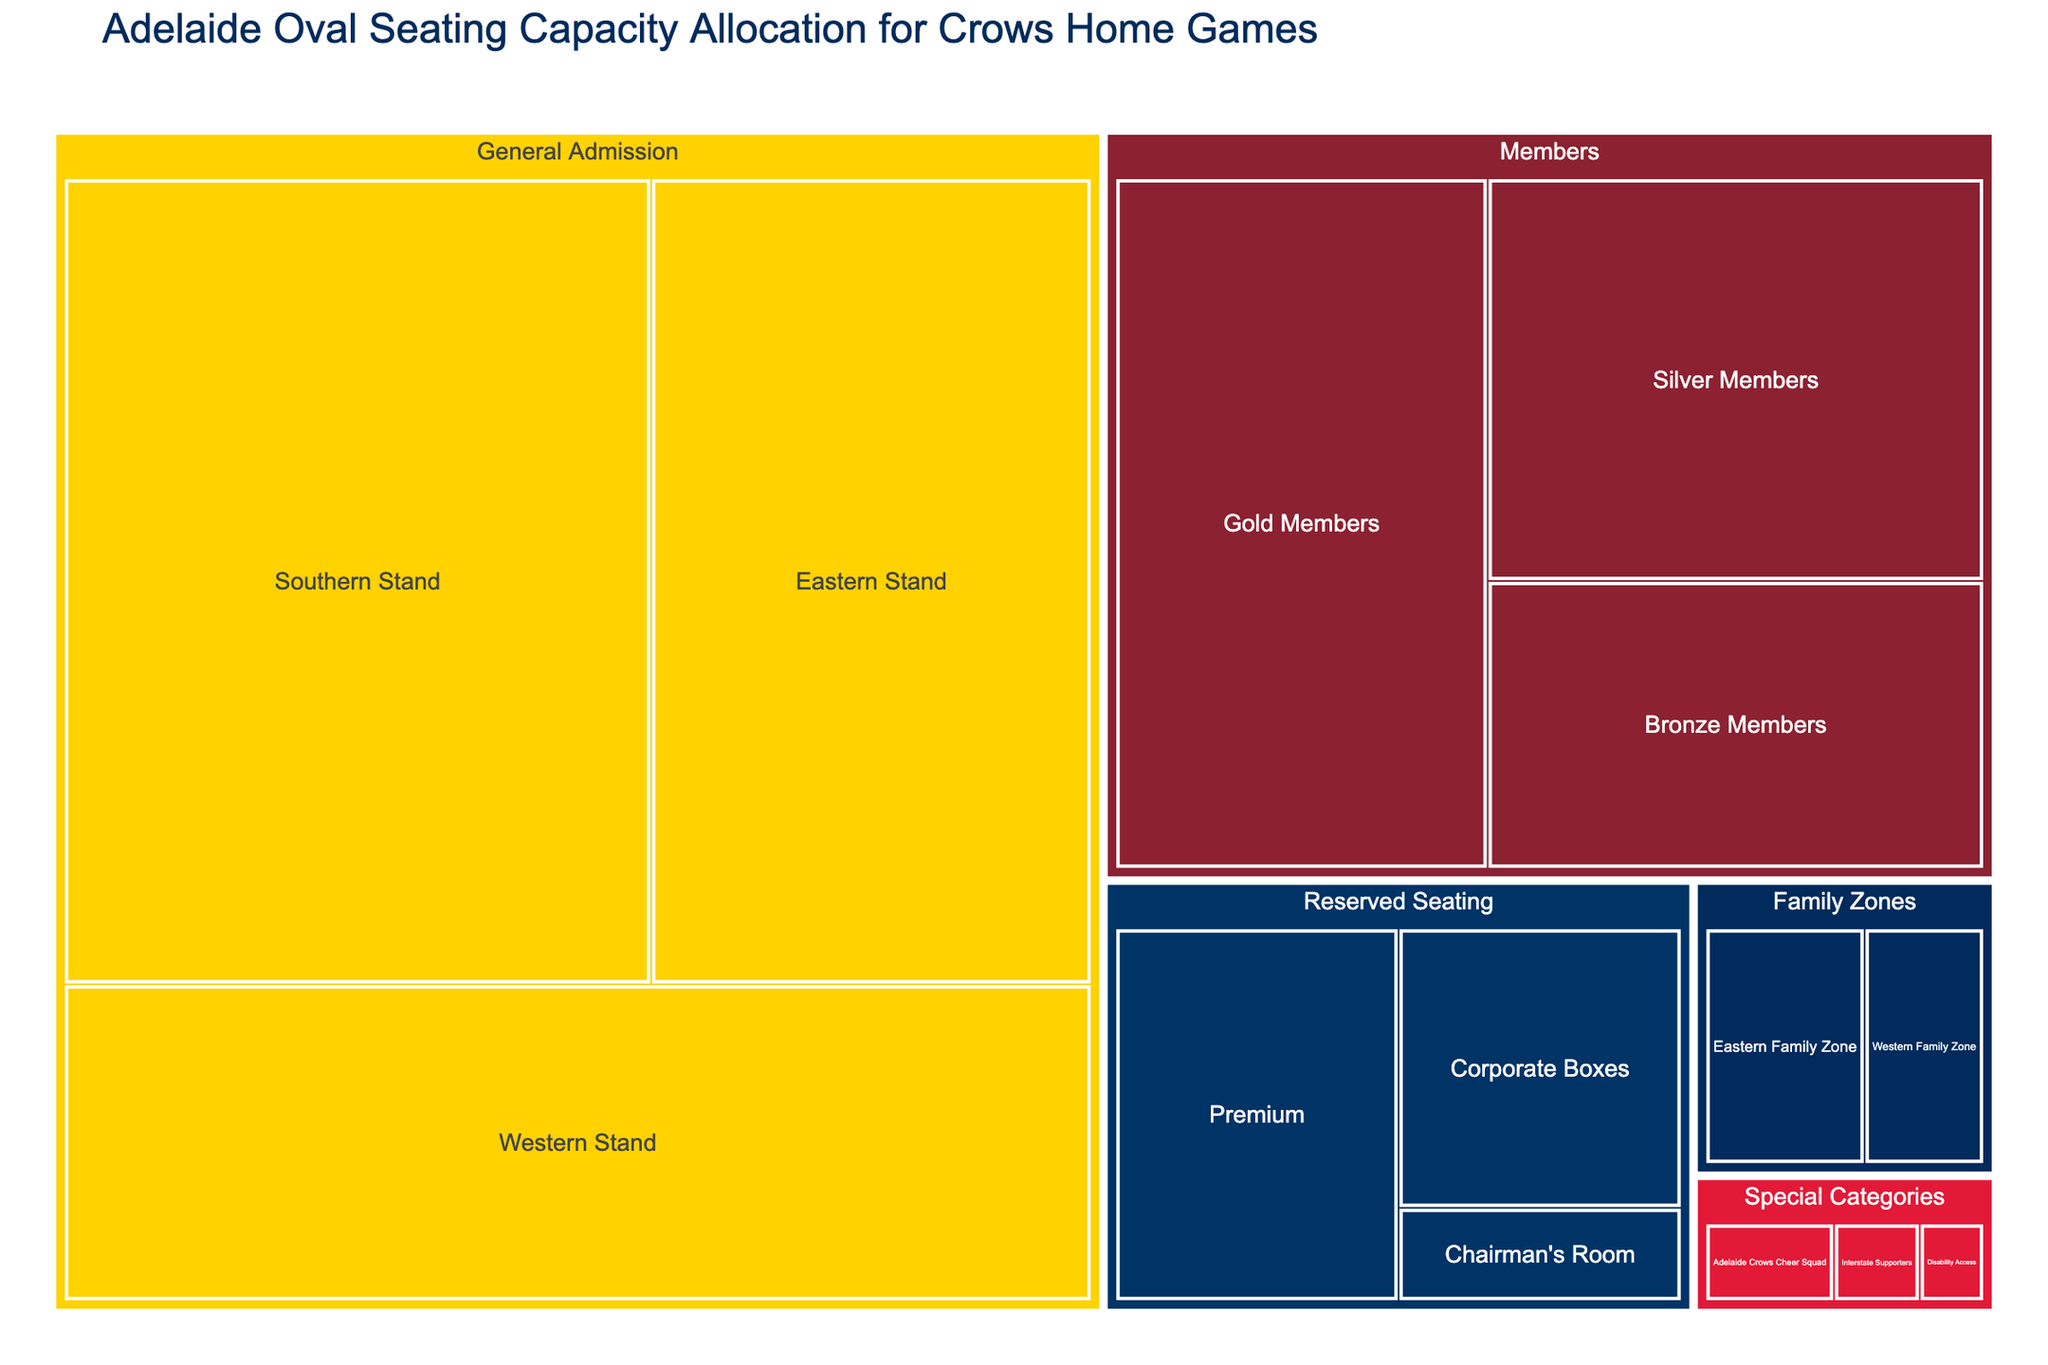Which stand has the highest general admission seating capacity? Find the part labeled 'General Admission' and compare the values for the Southern Stand (8000), Eastern Stand (6000), and Western Stand (5500). The Southern Stand has the highest value.
Answer: Southern Stand How many categories are represented in this treemap? Identify the top-level categories listed in the figure. They are General Admission, Members, Reserved Seating, Special Categories, and Family Zones. Count these categories.
Answer: 5 What is the total seating capacity for the 'Members' category? Sum the values within the 'Members' category: Gold Members (4500), Silver Members (3500), and Bronze Members (2500). \(4500 + 3500 + 2500\) = 10500.
Answer: 10500 Which category has the smallest seating capacity, and what is that capacity? Analyze the seating capacities of each top-level category: General Admission, Members, Reserved Seating, Special Categories, and Family Zones. Identify that 'Special Categories' has the smallest overall capacity. Within 'Special Categories', check the values: Adelaide Crows Cheer Squad (300), Interstate Supporters (200), and Disability Access (150). The minimum is 150 for Disability Access.
Answer: Special Categories, 150 Is the capacity of the Western Family Zone greater than the capacity of Corporate Boxes? Compare the seating capacity values listed for the Western Family Zone (600) and Corporate Boxes (1500). Determine that 600 is less than 1500.
Answer: No What is the combined capacity of the 'Reserved Seating' category? Locate the 'Reserved Seating' category and sum its subcategories: Premium (2000), Corporate Boxes (1500), and Chairman's Room (500). Calculate \(2000 + 1500 + 500\) = 4000.
Answer: 4000 Compare the capacity of 'Eastern Stand' within General Admission and the 'Eastern Family Zone'. Which one has a higher capacity? Look at the values for the Eastern Stand in 'General Admission' (6000) and Eastern Family Zone within 'Family Zones' (800). Compare these values to see that 6000 is greater than 800.
Answer: Eastern Stand within General Admission If you combine the capacities of all 'Special Categories', do they exceed the capacity of the 'Southern Stand' in General Admission? Calculate the total for 'Special Categories': Adelaide Crows Cheer Squad (300), Interstate Supporters (200), and Disability Access (150). \(300 + 200 + 150\) = 650. Compare this to the 'Southern Stand' in General Admission (8000) to see that the total does not exceed 8000.
Answer: No What percentage of the seating capacity does the 'General Admission' occupy relative to the total seating capacity displayed in the treemap? Calculate the total capacity of 'General Admission': Southern Stand (8000), Eastern Stand (6000), and Western Stand (5500). \(8000 + 6000 + 5500\) = 19500. Determine the total capacity of all categories: General Admission (19500) + Members (10500) + Reserved Seating (4000) + Special Categories (650) + Family Zones (1400). \(19500 + 10500 + 4000 + 650 + 1400\) = 36050. The percentage is \(\frac{19500}{36050} \times 100 = 54.1\%\).
Answer: 54.1% 